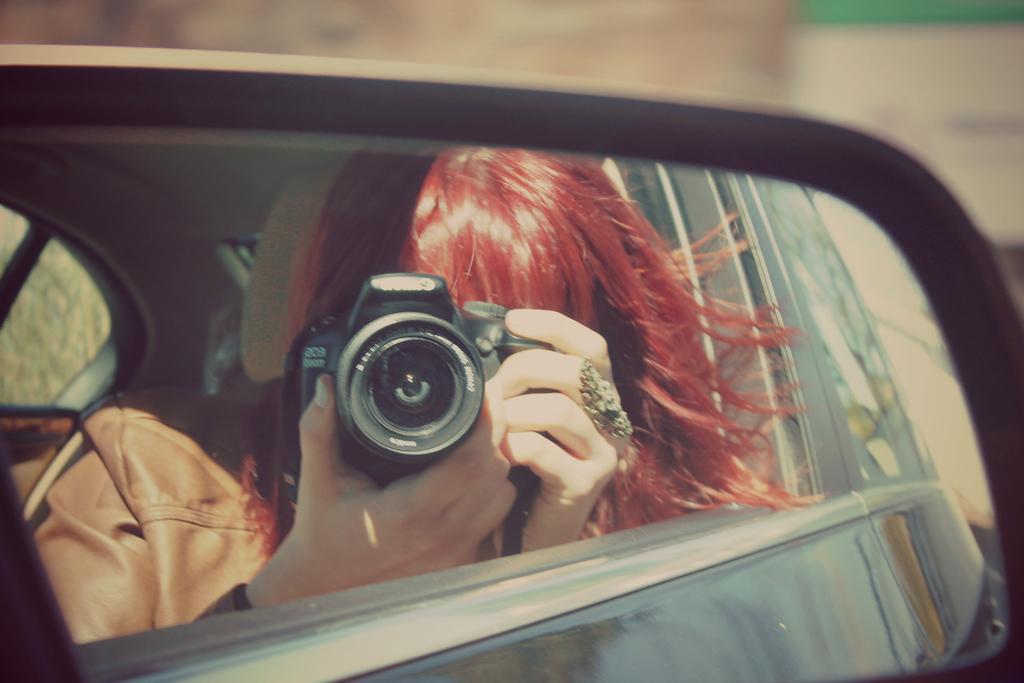Could you give a brief overview of what you see in this image? This image is taken outdoors. In this image the background is a little blurred. In the middle of the image there is a side mirror of a vehicle. We can see a woman holding a camera in her hands in the side mirror. 